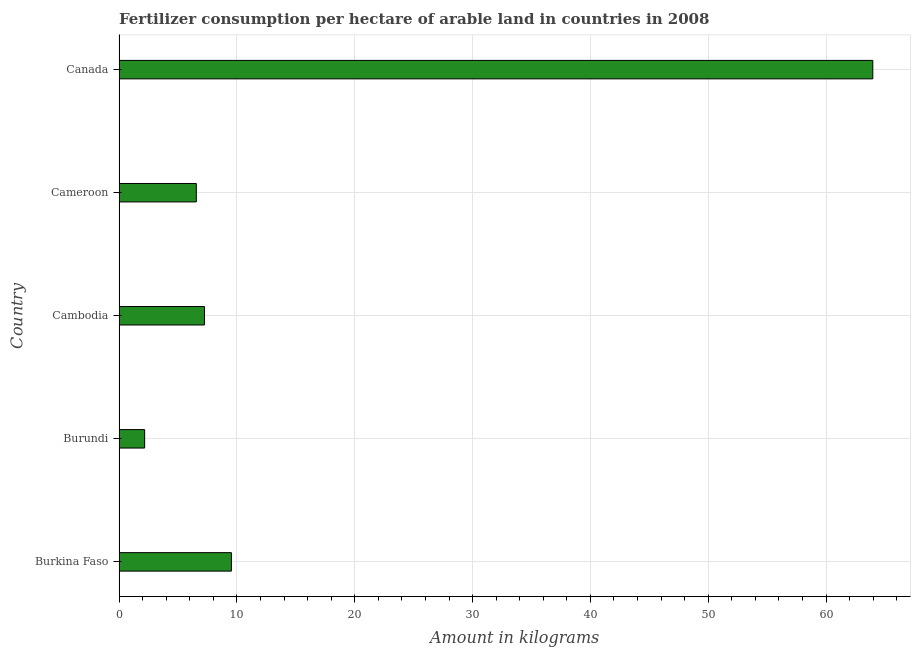Does the graph contain any zero values?
Offer a very short reply. No. Does the graph contain grids?
Give a very brief answer. Yes. What is the title of the graph?
Offer a terse response. Fertilizer consumption per hectare of arable land in countries in 2008 . What is the label or title of the X-axis?
Provide a short and direct response. Amount in kilograms. What is the label or title of the Y-axis?
Offer a very short reply. Country. What is the amount of fertilizer consumption in Burkina Faso?
Ensure brevity in your answer.  9.53. Across all countries, what is the maximum amount of fertilizer consumption?
Keep it short and to the point. 63.96. Across all countries, what is the minimum amount of fertilizer consumption?
Your answer should be compact. 2.17. In which country was the amount of fertilizer consumption minimum?
Ensure brevity in your answer.  Burundi. What is the sum of the amount of fertilizer consumption?
Provide a short and direct response. 89.48. What is the difference between the amount of fertilizer consumption in Burkina Faso and Cameroon?
Give a very brief answer. 2.98. What is the average amount of fertilizer consumption per country?
Your response must be concise. 17.89. What is the median amount of fertilizer consumption?
Offer a terse response. 7.25. In how many countries, is the amount of fertilizer consumption greater than 16 kg?
Ensure brevity in your answer.  1. What is the ratio of the amount of fertilizer consumption in Cambodia to that in Canada?
Your answer should be very brief. 0.11. Is the difference between the amount of fertilizer consumption in Burundi and Cambodia greater than the difference between any two countries?
Offer a terse response. No. What is the difference between the highest and the second highest amount of fertilizer consumption?
Your answer should be very brief. 54.43. Is the sum of the amount of fertilizer consumption in Burkina Faso and Canada greater than the maximum amount of fertilizer consumption across all countries?
Give a very brief answer. Yes. What is the difference between the highest and the lowest amount of fertilizer consumption?
Give a very brief answer. 61.79. How many bars are there?
Give a very brief answer. 5. Are all the bars in the graph horizontal?
Provide a succinct answer. Yes. What is the difference between two consecutive major ticks on the X-axis?
Offer a very short reply. 10. Are the values on the major ticks of X-axis written in scientific E-notation?
Keep it short and to the point. No. What is the Amount in kilograms in Burkina Faso?
Offer a very short reply. 9.53. What is the Amount in kilograms in Burundi?
Offer a very short reply. 2.17. What is the Amount in kilograms of Cambodia?
Your answer should be very brief. 7.25. What is the Amount in kilograms in Cameroon?
Keep it short and to the point. 6.56. What is the Amount in kilograms of Canada?
Keep it short and to the point. 63.96. What is the difference between the Amount in kilograms in Burkina Faso and Burundi?
Ensure brevity in your answer.  7.36. What is the difference between the Amount in kilograms in Burkina Faso and Cambodia?
Provide a succinct answer. 2.29. What is the difference between the Amount in kilograms in Burkina Faso and Cameroon?
Provide a succinct answer. 2.98. What is the difference between the Amount in kilograms in Burkina Faso and Canada?
Offer a terse response. -54.43. What is the difference between the Amount in kilograms in Burundi and Cambodia?
Your answer should be very brief. -5.08. What is the difference between the Amount in kilograms in Burundi and Cameroon?
Provide a short and direct response. -4.39. What is the difference between the Amount in kilograms in Burundi and Canada?
Make the answer very short. -61.79. What is the difference between the Amount in kilograms in Cambodia and Cameroon?
Keep it short and to the point. 0.69. What is the difference between the Amount in kilograms in Cambodia and Canada?
Ensure brevity in your answer.  -56.71. What is the difference between the Amount in kilograms in Cameroon and Canada?
Your answer should be very brief. -57.41. What is the ratio of the Amount in kilograms in Burkina Faso to that in Burundi?
Make the answer very short. 4.39. What is the ratio of the Amount in kilograms in Burkina Faso to that in Cambodia?
Provide a short and direct response. 1.31. What is the ratio of the Amount in kilograms in Burkina Faso to that in Cameroon?
Give a very brief answer. 1.45. What is the ratio of the Amount in kilograms in Burkina Faso to that in Canada?
Offer a terse response. 0.15. What is the ratio of the Amount in kilograms in Burundi to that in Cambodia?
Your answer should be compact. 0.3. What is the ratio of the Amount in kilograms in Burundi to that in Cameroon?
Provide a short and direct response. 0.33. What is the ratio of the Amount in kilograms in Burundi to that in Canada?
Your answer should be very brief. 0.03. What is the ratio of the Amount in kilograms in Cambodia to that in Cameroon?
Keep it short and to the point. 1.11. What is the ratio of the Amount in kilograms in Cambodia to that in Canada?
Keep it short and to the point. 0.11. What is the ratio of the Amount in kilograms in Cameroon to that in Canada?
Offer a very short reply. 0.1. 